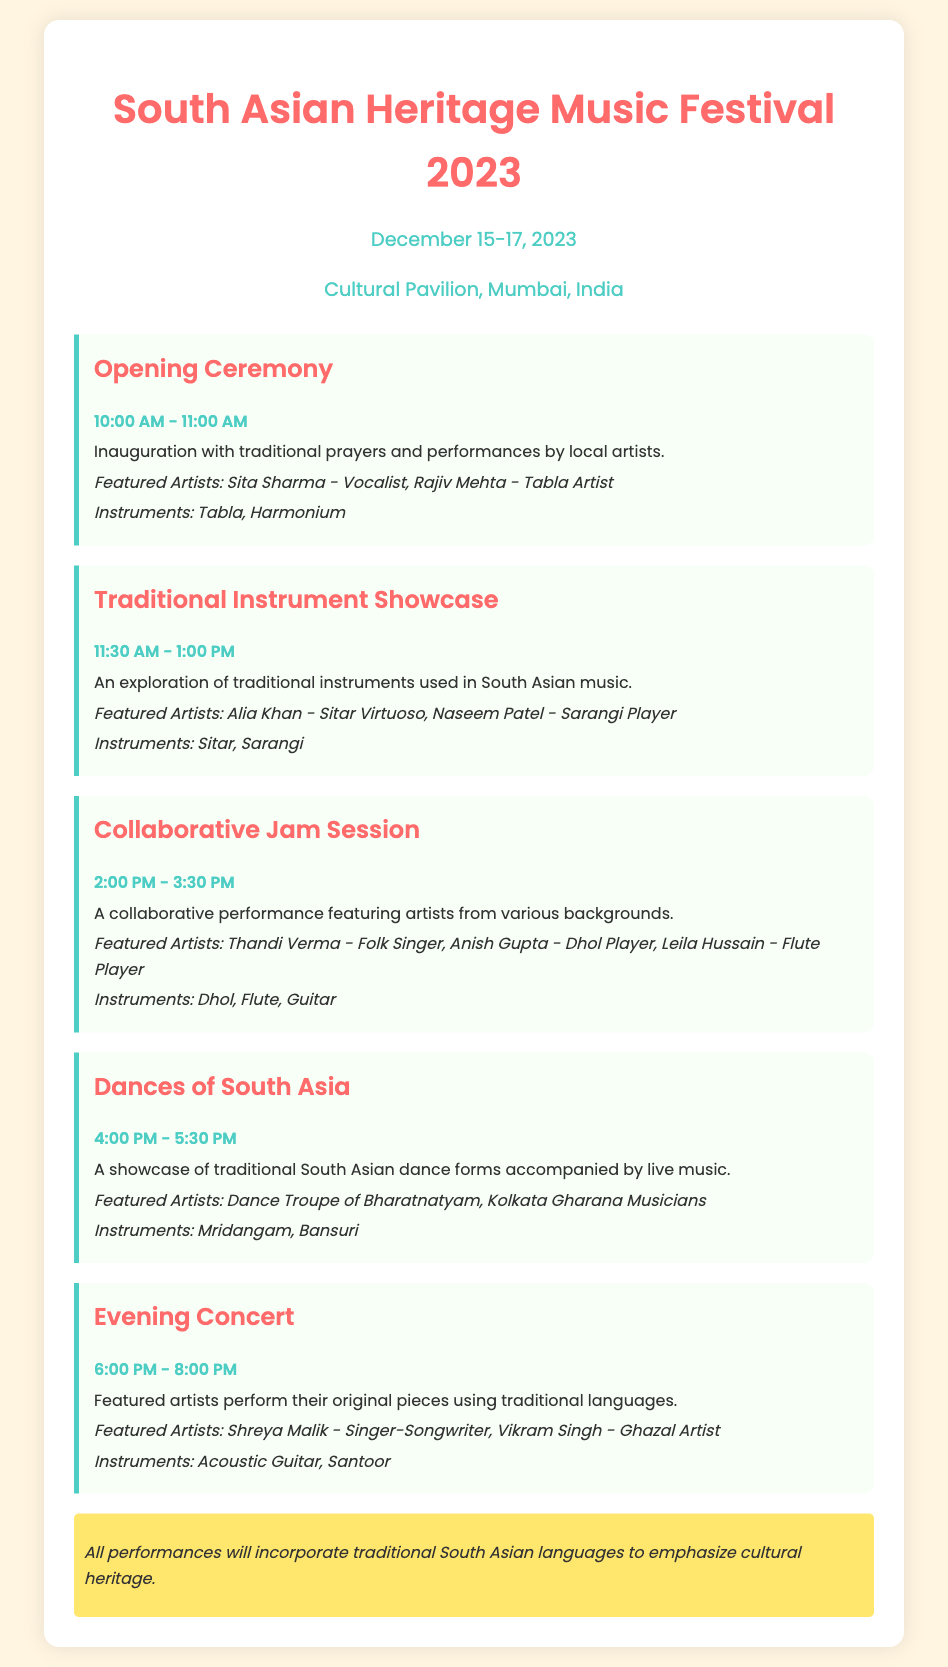What are the dates of the festival? The festival runs from December 15 to December 17, 2023, as stated in the document.
Answer: December 15-17, 2023 Who is the vocal artist featured in the Opening Ceremony? The document lists Sita Sharma as the vocalist in the Opening Ceremony.
Answer: Sita Sharma What instrument is played by Alia Khan? According to the agenda, Alia Khan is a sitar virtuoso.
Answer: Sitar What time does the Collaborative Jam Session begin? The document specifies that the Collaborative Jam Session starts at 2:00 PM.
Answer: 2:00 PM Which dance troupe is featured in the Dances of South Asia? The document refers to the "Dance Troupe of Bharatnatyam" as the featured troupe.
Answer: Dance Troupe of Bharatnatyam How many featured artists are listed for the Evening Concert? The Evening Concert features two artists, according to the information provided.
Answer: Two What instrument is associated with Vikram Singh? The document identifies Santoor as the instrument associated with Vikram Singh.
Answer: Santoor What is the ending time for the Traditional Instrument Showcase? According to the schedule, the Traditional Instrument Showcase ends at 1:00 PM.
Answer: 1:00 PM What language theme is emphasized in all performances? The document notes that all performances will incorporate traditional South Asian languages to emphasize cultural heritage.
Answer: Traditional South Asian languages 